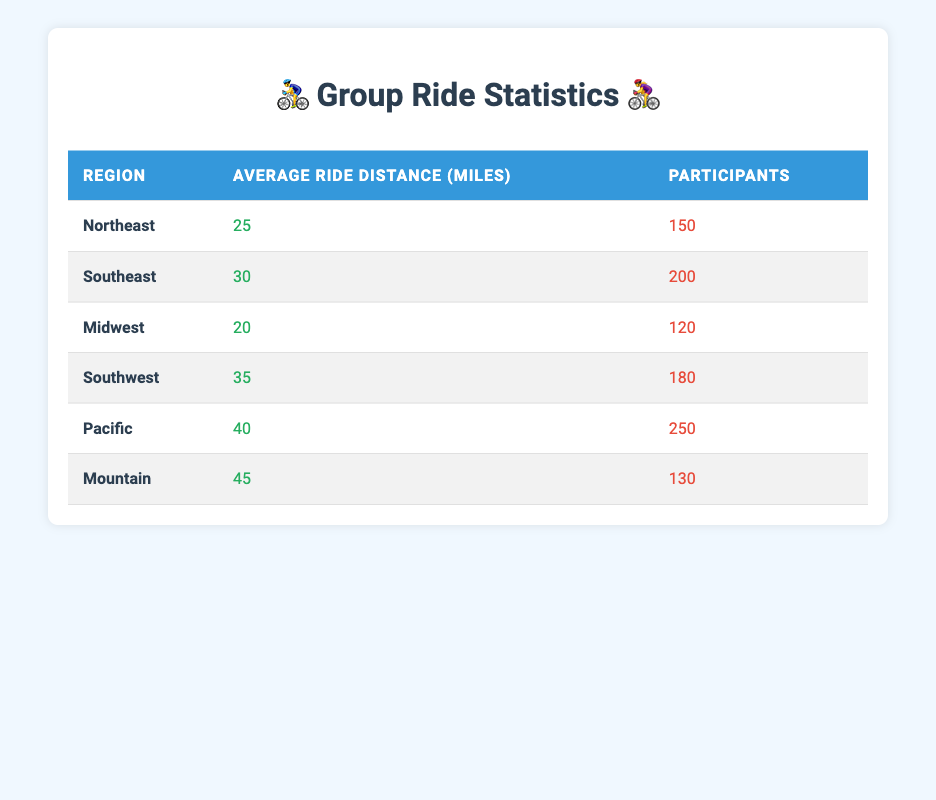What is the average ride distance in the Pacific region? The table shows that the average ride distance in the Pacific region is stated explicitly as 40 miles.
Answer: 40 miles How many participants were there in the Southwest region? According to the table, the number of participants in the Southwest region is listed as 180.
Answer: 180 Is the average ride distance greater in the Southeast than in the Midwest? The average ride distance in the Southeast is 30 miles, while in the Midwest it is 20 miles. Since 30 is greater than 20, the statement is true.
Answer: Yes What is the total number of participants across all regions? To find the total number of participants, we sum the participants from each region: 150 + 200 + 120 + 180 + 250 + 130 = 1030.
Answer: 1030 In which region did the least number of participants take part in group rides? By checking the participant counts across all regions, the Midwest has the least at 120 participants.
Answer: Midwest What is the difference between the average ride distances of the Pacific and Mountain regions? The average ride distance in the Pacific region is 40 miles, and in the Mountain region, it is 45 miles. The difference is calculated as 45 - 40 = 5 miles.
Answer: 5 miles How many participants would ride if we consider the Northeast and Southwest regions together? Adding the participants in the Northeast (150) and the Southwest (180) gives us a total of 150 + 180 = 330 participants.
Answer: 330 Is the average ride distance in the Northeast region less than 30 miles? The average ride distance in the Northeast is 25 miles, which is indeed less than 30 miles, making the statement true.
Answer: Yes Which region has the highest average ride distance, and what is that distance? From the table, the Pacific region has the highest average ride distance at 40 miles.
Answer: Pacific, 40 miles 